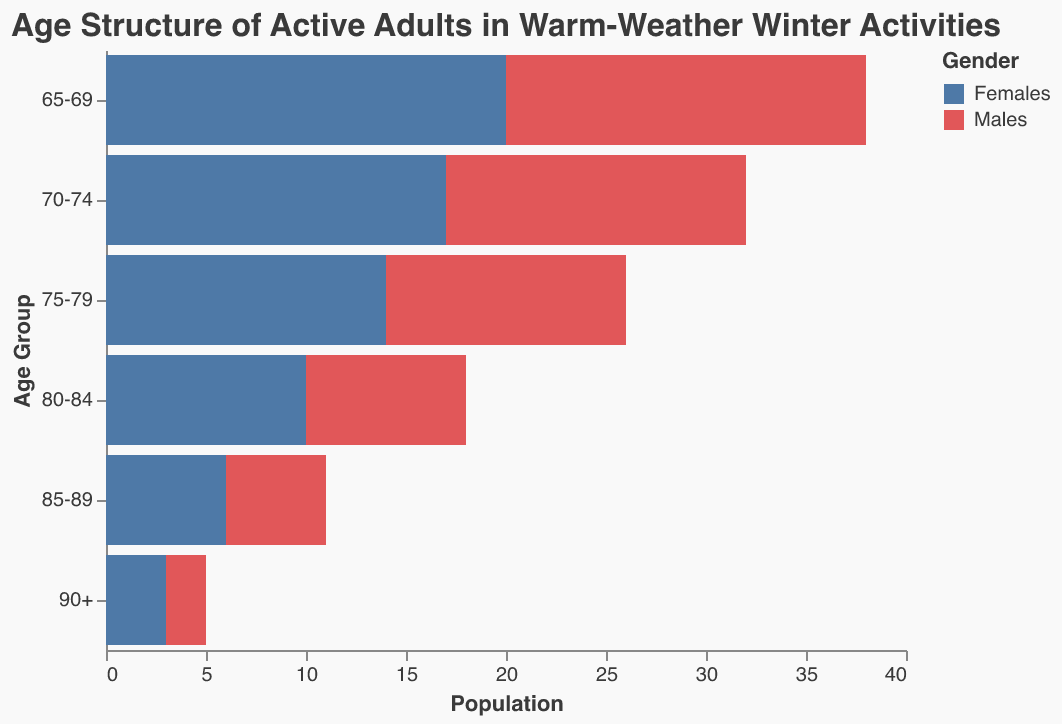What's the title of the graph? The title is located at the top of the graph and provides a summary of what the graph shows.
Answer: Age Structure of Active Adults in Warm-Weather Winter Activities How many age groups are represented in the graph? By counting the distinct categories on the y-axis of the graph, we can identify the number of age groups listed.
Answer: Six In the 75-79 age group, are there more males or females participating? Observe the lengths of the bars for the 75-79 age group. The bar with the larger magnitude indicates the gender with more participants.
Answer: Females Which age group has the highest number of male participants? Identify the bar for males with the highest absolute value (the longest bar) and match it to the corresponding age group on the y-axis.
Answer: 65-69 What is the total number of female participants in the 85-89 and 90+ age groups combined? Sum the values of female participants in the 85-89 and 90+ age groups from the graph.
Answer: 9 Which age group has the smallest difference in the number of male and female participants? Calculate the absolute differences for each age group and compare them to find the smallest one. For example, 20-18 = 2 for 65-69, 17-15 = 2 for 70-74, etc.
Answer: 65-69 and 70-74 Are there more participants in the 65-69 age group or the 80-84 age group? Sum the values of male and female participants in each age group and compare the totals. (18 + 20) for 65-69 and (8 + 10) for 80-84.
Answer: 65-69 What is the combined number of male and female participants in the 70-74 age group? Add up the values of male and female participants in the 70-74 age group.
Answer: 32 How does the population of males compare to females in the 90+ age group? Observe and compare the lengths of the bars for males and females in the 90+ age group.
Answer: There are more females Which age group shows the largest gender disparity in participation? Calculate the absolute differences between male and female participants for each age group and identify the largest difference.
Answer: 75-79 